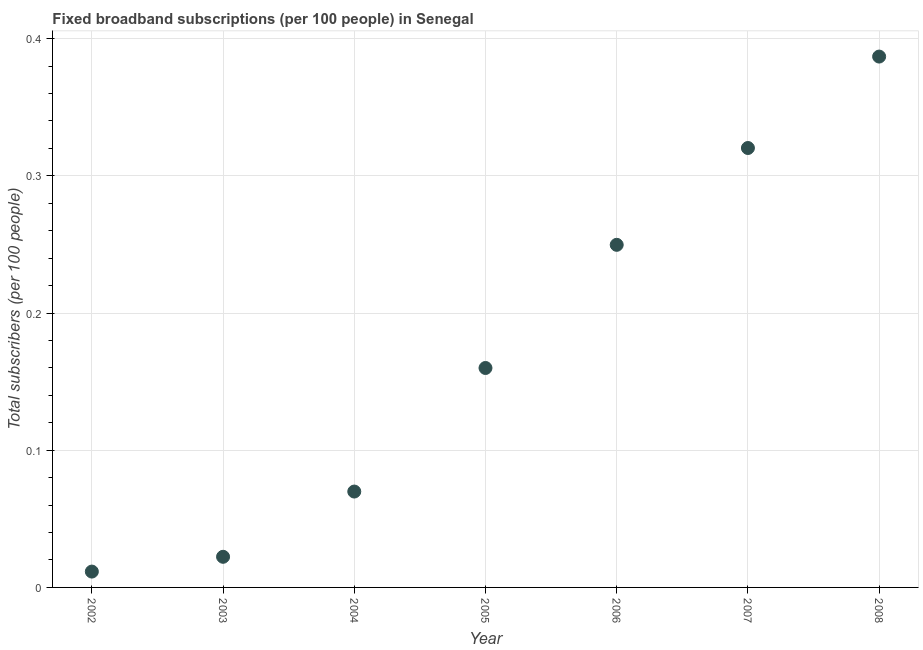What is the total number of fixed broadband subscriptions in 2005?
Offer a very short reply. 0.16. Across all years, what is the maximum total number of fixed broadband subscriptions?
Provide a short and direct response. 0.39. Across all years, what is the minimum total number of fixed broadband subscriptions?
Keep it short and to the point. 0.01. What is the sum of the total number of fixed broadband subscriptions?
Your answer should be compact. 1.22. What is the difference between the total number of fixed broadband subscriptions in 2002 and 2004?
Ensure brevity in your answer.  -0.06. What is the average total number of fixed broadband subscriptions per year?
Your answer should be very brief. 0.17. What is the median total number of fixed broadband subscriptions?
Your response must be concise. 0.16. In how many years, is the total number of fixed broadband subscriptions greater than 0.34 ?
Ensure brevity in your answer.  1. What is the ratio of the total number of fixed broadband subscriptions in 2004 to that in 2008?
Your answer should be very brief. 0.18. Is the total number of fixed broadband subscriptions in 2003 less than that in 2006?
Make the answer very short. Yes. Is the difference between the total number of fixed broadband subscriptions in 2005 and 2008 greater than the difference between any two years?
Make the answer very short. No. What is the difference between the highest and the second highest total number of fixed broadband subscriptions?
Provide a short and direct response. 0.07. Is the sum of the total number of fixed broadband subscriptions in 2005 and 2008 greater than the maximum total number of fixed broadband subscriptions across all years?
Your answer should be very brief. Yes. What is the difference between the highest and the lowest total number of fixed broadband subscriptions?
Offer a terse response. 0.38. In how many years, is the total number of fixed broadband subscriptions greater than the average total number of fixed broadband subscriptions taken over all years?
Keep it short and to the point. 3. How many dotlines are there?
Give a very brief answer. 1. How many years are there in the graph?
Keep it short and to the point. 7. What is the difference between two consecutive major ticks on the Y-axis?
Provide a short and direct response. 0.1. Are the values on the major ticks of Y-axis written in scientific E-notation?
Offer a terse response. No. Does the graph contain grids?
Provide a short and direct response. Yes. What is the title of the graph?
Offer a terse response. Fixed broadband subscriptions (per 100 people) in Senegal. What is the label or title of the X-axis?
Give a very brief answer. Year. What is the label or title of the Y-axis?
Your answer should be very brief. Total subscribers (per 100 people). What is the Total subscribers (per 100 people) in 2002?
Provide a short and direct response. 0.01. What is the Total subscribers (per 100 people) in 2003?
Make the answer very short. 0.02. What is the Total subscribers (per 100 people) in 2004?
Give a very brief answer. 0.07. What is the Total subscribers (per 100 people) in 2005?
Ensure brevity in your answer.  0.16. What is the Total subscribers (per 100 people) in 2006?
Offer a terse response. 0.25. What is the Total subscribers (per 100 people) in 2007?
Your answer should be very brief. 0.32. What is the Total subscribers (per 100 people) in 2008?
Ensure brevity in your answer.  0.39. What is the difference between the Total subscribers (per 100 people) in 2002 and 2003?
Ensure brevity in your answer.  -0.01. What is the difference between the Total subscribers (per 100 people) in 2002 and 2004?
Offer a terse response. -0.06. What is the difference between the Total subscribers (per 100 people) in 2002 and 2005?
Provide a succinct answer. -0.15. What is the difference between the Total subscribers (per 100 people) in 2002 and 2006?
Give a very brief answer. -0.24. What is the difference between the Total subscribers (per 100 people) in 2002 and 2007?
Offer a terse response. -0.31. What is the difference between the Total subscribers (per 100 people) in 2002 and 2008?
Offer a very short reply. -0.38. What is the difference between the Total subscribers (per 100 people) in 2003 and 2004?
Make the answer very short. -0.05. What is the difference between the Total subscribers (per 100 people) in 2003 and 2005?
Give a very brief answer. -0.14. What is the difference between the Total subscribers (per 100 people) in 2003 and 2006?
Ensure brevity in your answer.  -0.23. What is the difference between the Total subscribers (per 100 people) in 2003 and 2007?
Your response must be concise. -0.3. What is the difference between the Total subscribers (per 100 people) in 2003 and 2008?
Offer a terse response. -0.36. What is the difference between the Total subscribers (per 100 people) in 2004 and 2005?
Offer a very short reply. -0.09. What is the difference between the Total subscribers (per 100 people) in 2004 and 2006?
Offer a very short reply. -0.18. What is the difference between the Total subscribers (per 100 people) in 2004 and 2007?
Ensure brevity in your answer.  -0.25. What is the difference between the Total subscribers (per 100 people) in 2004 and 2008?
Your response must be concise. -0.32. What is the difference between the Total subscribers (per 100 people) in 2005 and 2006?
Offer a terse response. -0.09. What is the difference between the Total subscribers (per 100 people) in 2005 and 2007?
Ensure brevity in your answer.  -0.16. What is the difference between the Total subscribers (per 100 people) in 2005 and 2008?
Make the answer very short. -0.23. What is the difference between the Total subscribers (per 100 people) in 2006 and 2007?
Provide a short and direct response. -0.07. What is the difference between the Total subscribers (per 100 people) in 2006 and 2008?
Give a very brief answer. -0.14. What is the difference between the Total subscribers (per 100 people) in 2007 and 2008?
Offer a very short reply. -0.07. What is the ratio of the Total subscribers (per 100 people) in 2002 to that in 2003?
Offer a very short reply. 0.52. What is the ratio of the Total subscribers (per 100 people) in 2002 to that in 2004?
Provide a succinct answer. 0.17. What is the ratio of the Total subscribers (per 100 people) in 2002 to that in 2005?
Provide a succinct answer. 0.07. What is the ratio of the Total subscribers (per 100 people) in 2002 to that in 2006?
Provide a short and direct response. 0.05. What is the ratio of the Total subscribers (per 100 people) in 2002 to that in 2007?
Keep it short and to the point. 0.04. What is the ratio of the Total subscribers (per 100 people) in 2002 to that in 2008?
Provide a short and direct response. 0.03. What is the ratio of the Total subscribers (per 100 people) in 2003 to that in 2004?
Offer a terse response. 0.32. What is the ratio of the Total subscribers (per 100 people) in 2003 to that in 2005?
Make the answer very short. 0.14. What is the ratio of the Total subscribers (per 100 people) in 2003 to that in 2006?
Your answer should be compact. 0.09. What is the ratio of the Total subscribers (per 100 people) in 2003 to that in 2007?
Your answer should be very brief. 0.07. What is the ratio of the Total subscribers (per 100 people) in 2003 to that in 2008?
Your response must be concise. 0.06. What is the ratio of the Total subscribers (per 100 people) in 2004 to that in 2005?
Your answer should be compact. 0.44. What is the ratio of the Total subscribers (per 100 people) in 2004 to that in 2006?
Give a very brief answer. 0.28. What is the ratio of the Total subscribers (per 100 people) in 2004 to that in 2007?
Offer a very short reply. 0.22. What is the ratio of the Total subscribers (per 100 people) in 2004 to that in 2008?
Offer a terse response. 0.18. What is the ratio of the Total subscribers (per 100 people) in 2005 to that in 2006?
Your answer should be compact. 0.64. What is the ratio of the Total subscribers (per 100 people) in 2005 to that in 2007?
Provide a short and direct response. 0.5. What is the ratio of the Total subscribers (per 100 people) in 2005 to that in 2008?
Provide a short and direct response. 0.41. What is the ratio of the Total subscribers (per 100 people) in 2006 to that in 2007?
Offer a terse response. 0.78. What is the ratio of the Total subscribers (per 100 people) in 2006 to that in 2008?
Give a very brief answer. 0.65. What is the ratio of the Total subscribers (per 100 people) in 2007 to that in 2008?
Your answer should be very brief. 0.83. 